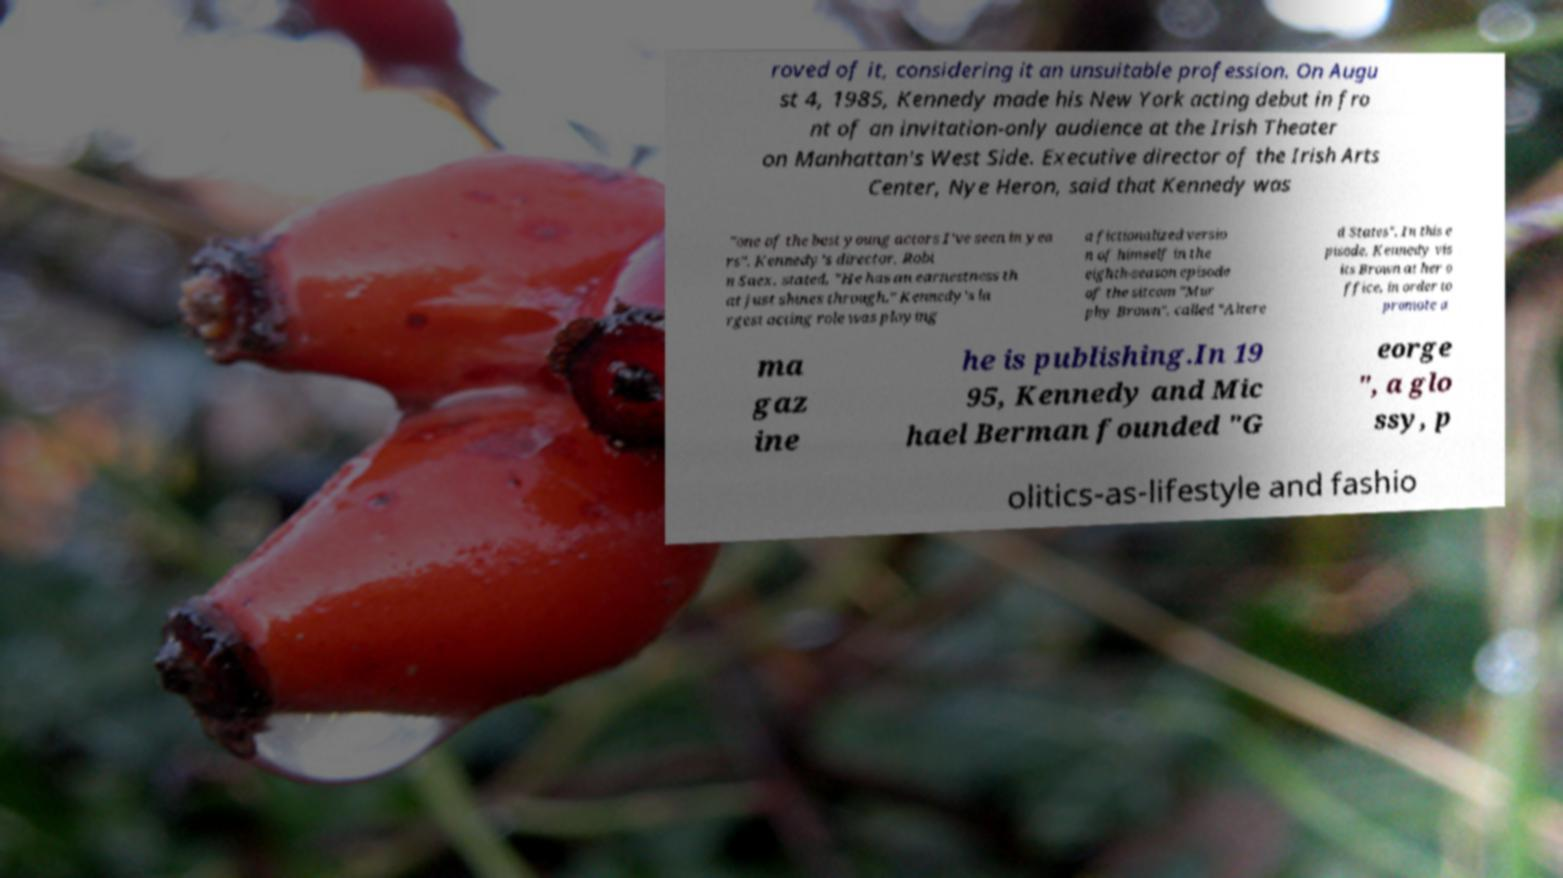Could you extract and type out the text from this image? roved of it, considering it an unsuitable profession. On Augu st 4, 1985, Kennedy made his New York acting debut in fro nt of an invitation-only audience at the Irish Theater on Manhattan's West Side. Executive director of the Irish Arts Center, Nye Heron, said that Kennedy was "one of the best young actors I've seen in yea rs". Kennedy's director, Robi n Saex, stated, "He has an earnestness th at just shines through." Kennedy's la rgest acting role was playing a fictionalized versio n of himself in the eighth-season episode of the sitcom "Mur phy Brown", called "Altere d States". In this e pisode, Kennedy vis its Brown at her o ffice, in order to promote a ma gaz ine he is publishing.In 19 95, Kennedy and Mic hael Berman founded "G eorge ", a glo ssy, p olitics-as-lifestyle and fashio 